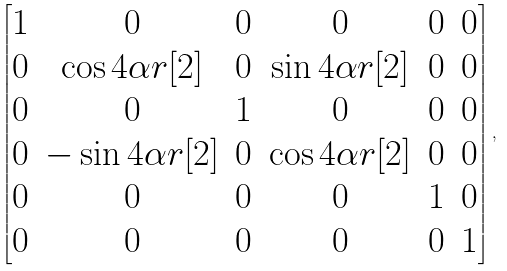Convert formula to latex. <formula><loc_0><loc_0><loc_500><loc_500>\begin{bmatrix} 1 & 0 & 0 & 0 & 0 & 0 \\ 0 & \cos 4 \alpha r [ 2 ] & 0 & \sin 4 \alpha r [ 2 ] & 0 & 0 \\ 0 & 0 & 1 & 0 & 0 & 0 \\ 0 & - \sin 4 \alpha r [ 2 ] & 0 & \cos 4 \alpha r [ 2 ] & 0 & 0 \\ 0 & 0 & 0 & 0 & 1 & 0 \\ 0 & 0 & 0 & 0 & 0 & 1 \end{bmatrix} ,</formula> 